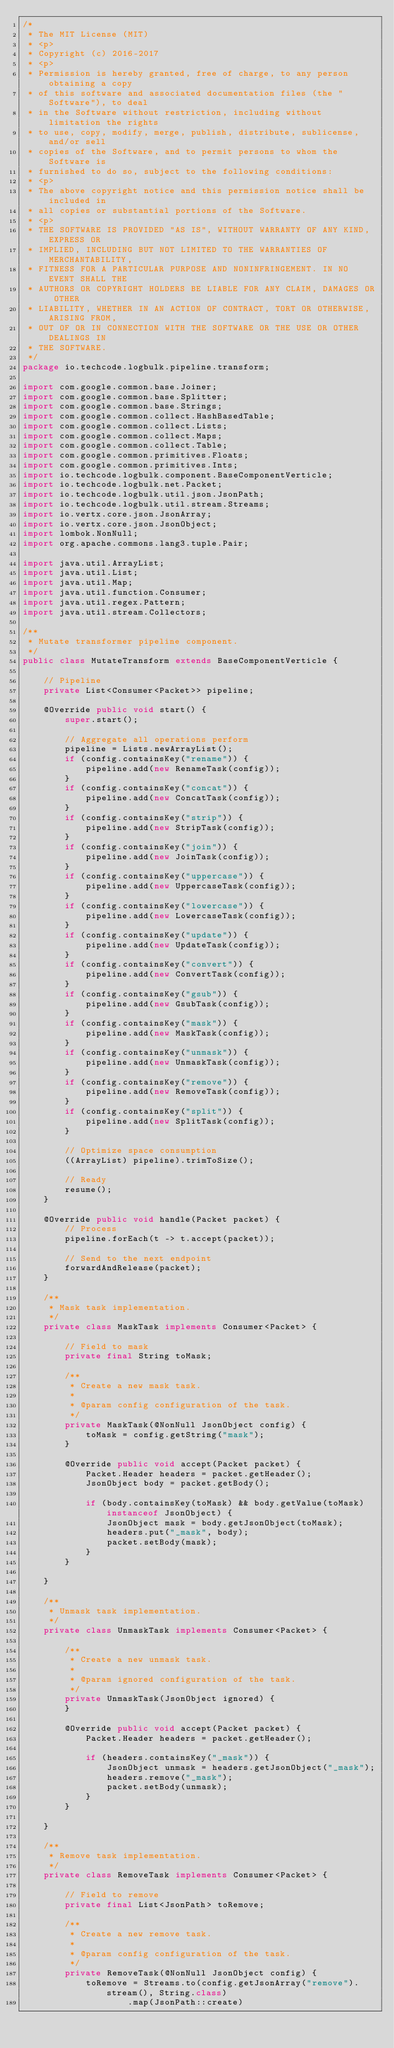Convert code to text. <code><loc_0><loc_0><loc_500><loc_500><_Java_>/*
 * The MIT License (MIT)
 * <p>
 * Copyright (c) 2016-2017
 * <p>
 * Permission is hereby granted, free of charge, to any person obtaining a copy
 * of this software and associated documentation files (the "Software"), to deal
 * in the Software without restriction, including without limitation the rights
 * to use, copy, modify, merge, publish, distribute, sublicense, and/or sell
 * copies of the Software, and to permit persons to whom the Software is
 * furnished to do so, subject to the following conditions:
 * <p>
 * The above copyright notice and this permission notice shall be included in
 * all copies or substantial portions of the Software.
 * <p>
 * THE SOFTWARE IS PROVIDED "AS IS", WITHOUT WARRANTY OF ANY KIND, EXPRESS OR
 * IMPLIED, INCLUDING BUT NOT LIMITED TO THE WARRANTIES OF MERCHANTABILITY,
 * FITNESS FOR A PARTICULAR PURPOSE AND NONINFRINGEMENT. IN NO EVENT SHALL THE
 * AUTHORS OR COPYRIGHT HOLDERS BE LIABLE FOR ANY CLAIM, DAMAGES OR OTHER
 * LIABILITY, WHETHER IN AN ACTION OF CONTRACT, TORT OR OTHERWISE, ARISING FROM,
 * OUT OF OR IN CONNECTION WITH THE SOFTWARE OR THE USE OR OTHER DEALINGS IN
 * THE SOFTWARE.
 */
package io.techcode.logbulk.pipeline.transform;

import com.google.common.base.Joiner;
import com.google.common.base.Splitter;
import com.google.common.base.Strings;
import com.google.common.collect.HashBasedTable;
import com.google.common.collect.Lists;
import com.google.common.collect.Maps;
import com.google.common.collect.Table;
import com.google.common.primitives.Floats;
import com.google.common.primitives.Ints;
import io.techcode.logbulk.component.BaseComponentVerticle;
import io.techcode.logbulk.net.Packet;
import io.techcode.logbulk.util.json.JsonPath;
import io.techcode.logbulk.util.stream.Streams;
import io.vertx.core.json.JsonArray;
import io.vertx.core.json.JsonObject;
import lombok.NonNull;
import org.apache.commons.lang3.tuple.Pair;

import java.util.ArrayList;
import java.util.List;
import java.util.Map;
import java.util.function.Consumer;
import java.util.regex.Pattern;
import java.util.stream.Collectors;

/**
 * Mutate transformer pipeline component.
 */
public class MutateTransform extends BaseComponentVerticle {

    // Pipeline
    private List<Consumer<Packet>> pipeline;

    @Override public void start() {
        super.start();

        // Aggregate all operations perform
        pipeline = Lists.newArrayList();
        if (config.containsKey("rename")) {
            pipeline.add(new RenameTask(config));
        }
        if (config.containsKey("concat")) {
            pipeline.add(new ConcatTask(config));
        }
        if (config.containsKey("strip")) {
            pipeline.add(new StripTask(config));
        }
        if (config.containsKey("join")) {
            pipeline.add(new JoinTask(config));
        }
        if (config.containsKey("uppercase")) {
            pipeline.add(new UppercaseTask(config));
        }
        if (config.containsKey("lowercase")) {
            pipeline.add(new LowercaseTask(config));
        }
        if (config.containsKey("update")) {
            pipeline.add(new UpdateTask(config));
        }
        if (config.containsKey("convert")) {
            pipeline.add(new ConvertTask(config));
        }
        if (config.containsKey("gsub")) {
            pipeline.add(new GsubTask(config));
        }
        if (config.containsKey("mask")) {
            pipeline.add(new MaskTask(config));
        }
        if (config.containsKey("unmask")) {
            pipeline.add(new UnmaskTask(config));
        }
        if (config.containsKey("remove")) {
            pipeline.add(new RemoveTask(config));
        }
        if (config.containsKey("split")) {
            pipeline.add(new SplitTask(config));
        }

        // Optimize space consumption
        ((ArrayList) pipeline).trimToSize();

        // Ready
        resume();
    }

    @Override public void handle(Packet packet) {
        // Process
        pipeline.forEach(t -> t.accept(packet));

        // Send to the next endpoint
        forwardAndRelease(packet);
    }

    /**
     * Mask task implementation.
     */
    private class MaskTask implements Consumer<Packet> {

        // Field to mask
        private final String toMask;

        /**
         * Create a new mask task.
         *
         * @param config configuration of the task.
         */
        private MaskTask(@NonNull JsonObject config) {
            toMask = config.getString("mask");
        }

        @Override public void accept(Packet packet) {
            Packet.Header headers = packet.getHeader();
            JsonObject body = packet.getBody();

            if (body.containsKey(toMask) && body.getValue(toMask) instanceof JsonObject) {
                JsonObject mask = body.getJsonObject(toMask);
                headers.put("_mask", body);
                packet.setBody(mask);
            }
        }

    }

    /**
     * Unmask task implementation.
     */
    private class UnmaskTask implements Consumer<Packet> {

        /**
         * Create a new unmask task.
         *
         * @param ignored configuration of the task.
         */
        private UnmaskTask(JsonObject ignored) {
        }

        @Override public void accept(Packet packet) {
            Packet.Header headers = packet.getHeader();

            if (headers.containsKey("_mask")) {
                JsonObject unmask = headers.getJsonObject("_mask");
                headers.remove("_mask");
                packet.setBody(unmask);
            }
        }

    }

    /**
     * Remove task implementation.
     */
    private class RemoveTask implements Consumer<Packet> {

        // Field to remove
        private final List<JsonPath> toRemove;

        /**
         * Create a new remove task.
         *
         * @param config configuration of the task.
         */
        private RemoveTask(@NonNull JsonObject config) {
            toRemove = Streams.to(config.getJsonArray("remove").stream(), String.class)
                    .map(JsonPath::create)</code> 